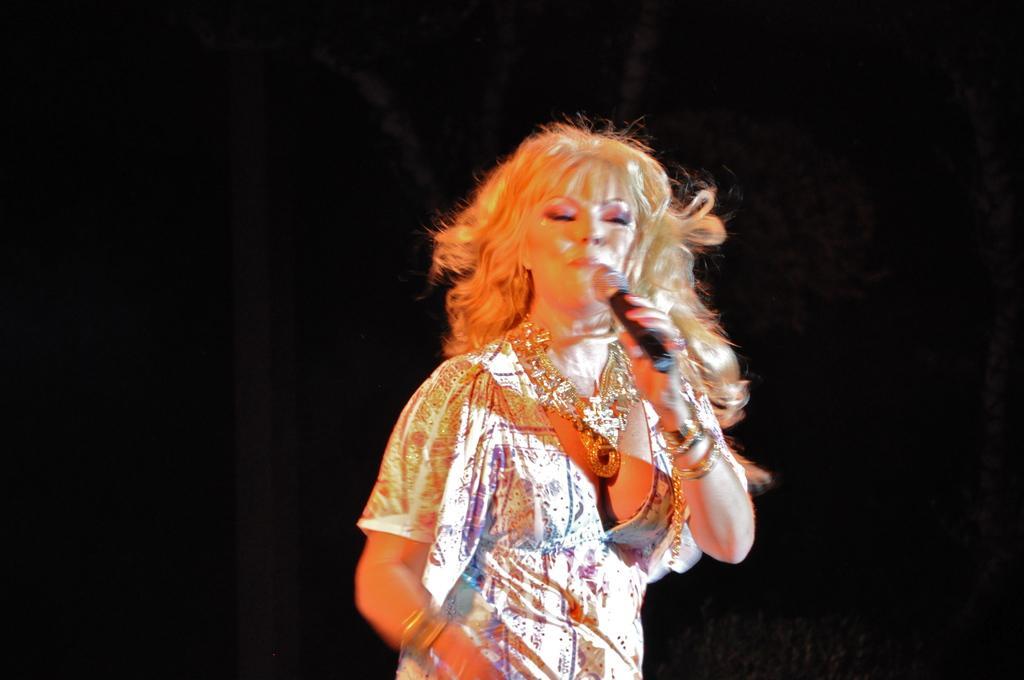In one or two sentences, can you explain what this image depicts? A woman is singing with a mic in her hand. 